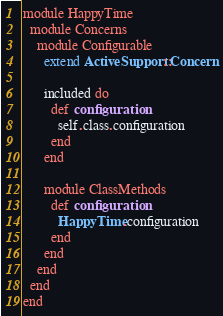<code> <loc_0><loc_0><loc_500><loc_500><_Ruby_>module HappyTime
  module Concerns
    module Configurable
      extend ActiveSupport::Concern

      included do
        def configuration
          self.class.configuration
        end
      end

      module ClassMethods
        def configuration
          HappyTime.configuration
        end
      end
    end
  end
end</code> 